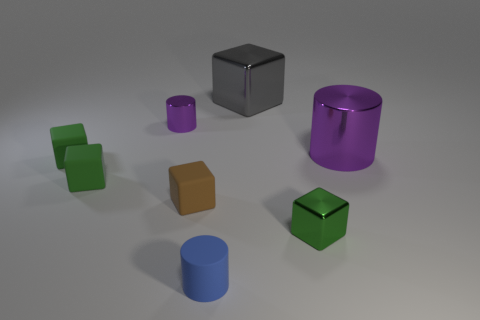There is a brown object that is the same size as the rubber cylinder; what is its material?
Your answer should be compact. Rubber. What number of other things are there of the same material as the large gray block
Give a very brief answer. 3. The object that is both in front of the tiny brown rubber block and to the right of the blue cylinder is what color?
Your answer should be very brief. Green. What number of things are either small cylinders in front of the tiny green shiny thing or green matte cubes?
Your response must be concise. 3. How many other objects are there of the same color as the tiny metal block?
Your answer should be compact. 2. Are there an equal number of tiny objects that are in front of the small blue object and small cyan things?
Offer a very short reply. Yes. What number of tiny things are behind the tiny thing that is in front of the metal cube in front of the small purple metallic cylinder?
Offer a terse response. 5. Do the gray shiny thing and the purple cylinder that is on the right side of the tiny brown object have the same size?
Provide a short and direct response. Yes. How many small cyan metal spheres are there?
Your answer should be compact. 0. There is a metal block that is in front of the small shiny cylinder; is its size the same as the metallic cube behind the large cylinder?
Your answer should be compact. No. 